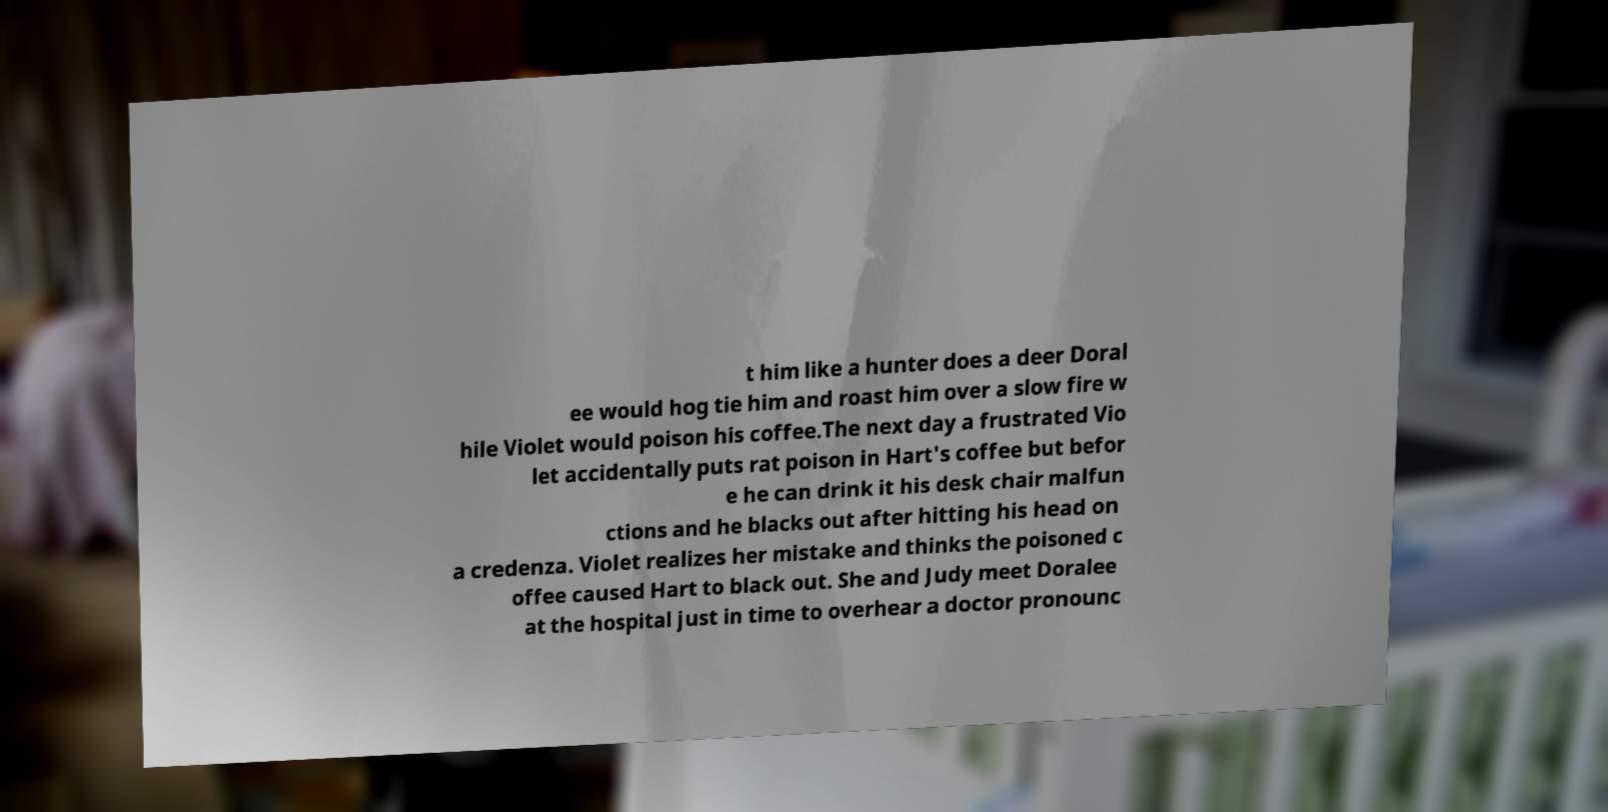Could you assist in decoding the text presented in this image and type it out clearly? t him like a hunter does a deer Doral ee would hog tie him and roast him over a slow fire w hile Violet would poison his coffee.The next day a frustrated Vio let accidentally puts rat poison in Hart's coffee but befor e he can drink it his desk chair malfun ctions and he blacks out after hitting his head on a credenza. Violet realizes her mistake and thinks the poisoned c offee caused Hart to black out. She and Judy meet Doralee at the hospital just in time to overhear a doctor pronounc 